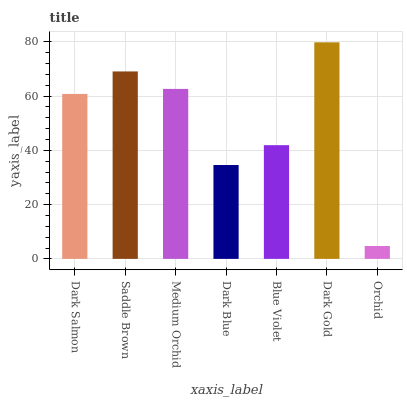Is Orchid the minimum?
Answer yes or no. Yes. Is Dark Gold the maximum?
Answer yes or no. Yes. Is Saddle Brown the minimum?
Answer yes or no. No. Is Saddle Brown the maximum?
Answer yes or no. No. Is Saddle Brown greater than Dark Salmon?
Answer yes or no. Yes. Is Dark Salmon less than Saddle Brown?
Answer yes or no. Yes. Is Dark Salmon greater than Saddle Brown?
Answer yes or no. No. Is Saddle Brown less than Dark Salmon?
Answer yes or no. No. Is Dark Salmon the high median?
Answer yes or no. Yes. Is Dark Salmon the low median?
Answer yes or no. Yes. Is Dark Blue the high median?
Answer yes or no. No. Is Saddle Brown the low median?
Answer yes or no. No. 